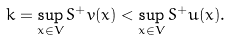<formula> <loc_0><loc_0><loc_500><loc_500>k = \sup _ { x \in V } S ^ { + } v ( x ) < \sup _ { x \in V } S ^ { + } u ( x ) .</formula> 